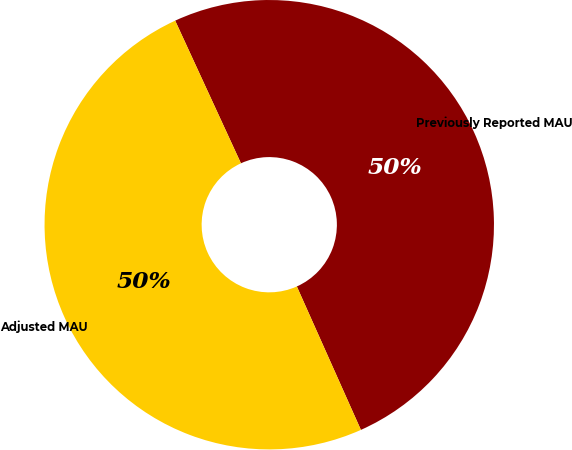Convert chart to OTSL. <chart><loc_0><loc_0><loc_500><loc_500><pie_chart><fcel>Previously Reported MAU<fcel>Adjusted MAU<nl><fcel>50.19%<fcel>49.81%<nl></chart> 